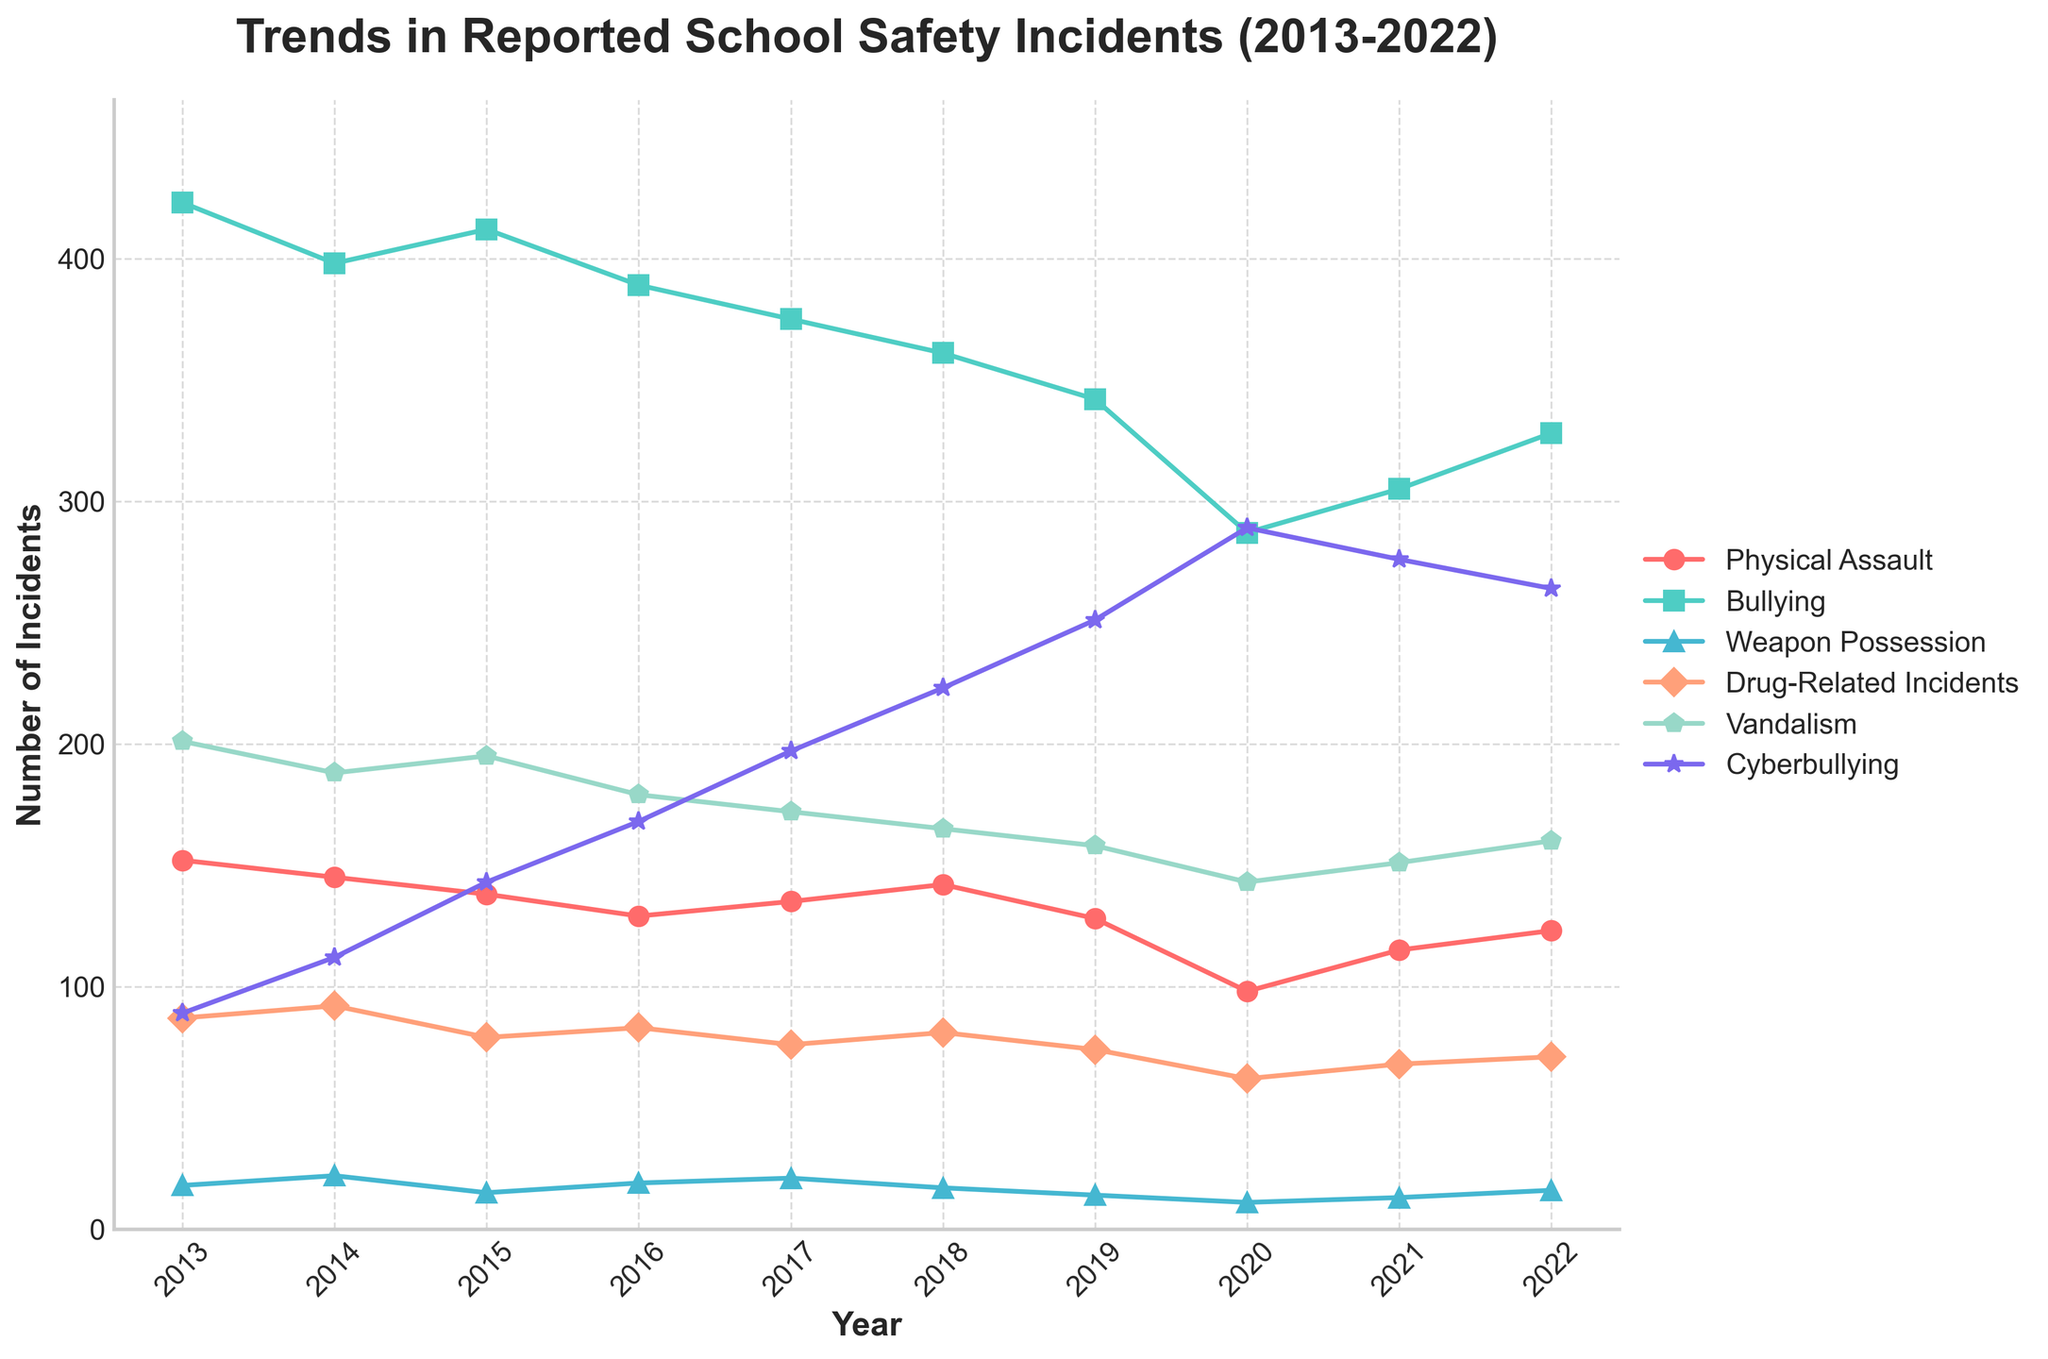Which type of incident increased the most from 2013 to 2022? Observe the data points for each type of incident in 2013 and 2022. The differences are: Physical Assault (-29), Bullying (-95), Weapon Possession (-2), Drug-Related Incidents (-16), Vandalism (-41), and Cyberbullying (175). The highest increase is in Cyberbullying.
Answer: Cyberbullying How many total incidents of Physical Assault and Vandalism were reported in 2018? Sum up the incidents of Physical Assault and Vandalism in 2018. Physical Assault (142) + Vandalism (165) = 307.
Answer: 307 Which type of incident had the highest number of reported cases in 2020? Look at the data points for each type of incident in 2020. Cyberbullying has the highest number with 289 cases.
Answer: Cyberbullying Compare the trend of Bullying and Drug-Related Incidents. Did both decrease from 2013 to 2022? Check the data values for Bullying (423 to 328) and Drug-Related Incidents (87 to 71) from 2013 to 2022. Both decreased.
Answer: Yes What is the average number of reported Weapon Possession incidents over the 10-year period? Sum the incidents of Weapon Possession from 2013 to 2022 and divide by 10. (18 + 22 + 15 + 19 + 21 + 17 + 14 + 11 + 13 + 16) = 166. Average = 166 / 10 = 16.6.
Answer: 16.6 By how much did the number of Drug-Related Incidents change from 2019 to 2020? Subtract the number of Drug-Related Incidents in 2019 (74) from 2020 (62). 74 - 62 = 12.
Answer: 12 Which type of incident shows the most consistent decrease in the number of incidents over the 10-year period? Look at the trends for each type of incident over the 10-year period. Bullying consistently decreased from 423 to 328.
Answer: Bullying In which year did Physical Assault incidents hit their lowest value? Find the year when Physical Assault incidents are the lowest. The lowest value is 98 in 2020.
Answer: 2020 Which years saw an increase in Cyberbullying incidents compared to the previous year? Observe the trend line for Cyberbullying incidents and see which years increased compared to the previous year. The years are 2014, 2015, 2016, 2017, 2018, 2019, 2020, and 2021.
Answer: 2014, 2015, 2016, 2017, 2018, 2019, 2020, 2021 